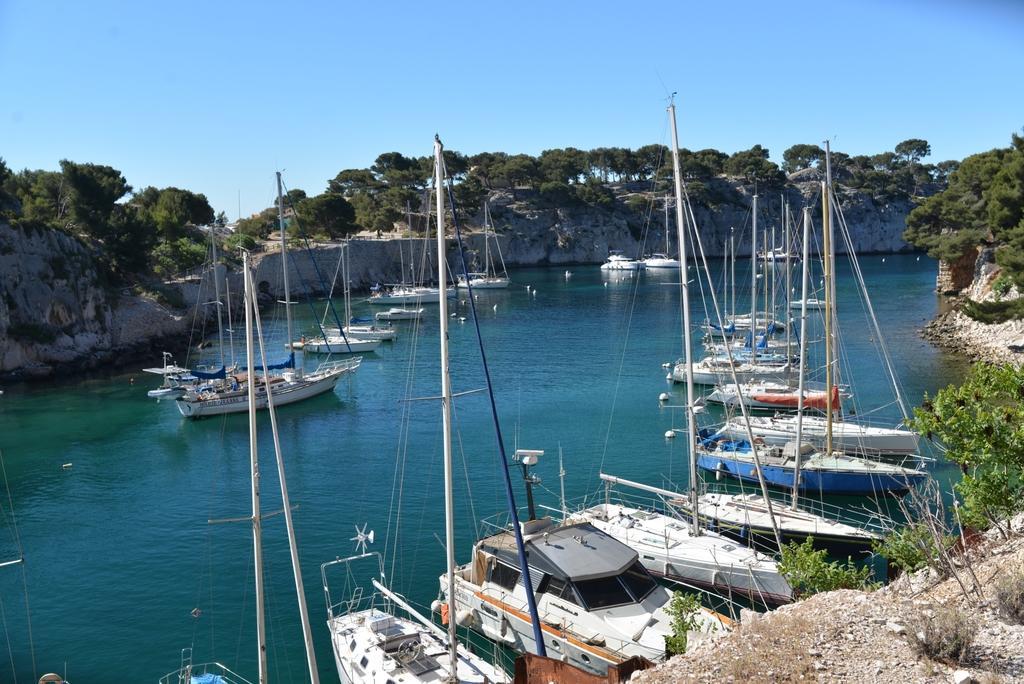Describe this image in one or two sentences. In this image I can see the boats on the water. I can see the water in blue color. To the side of the water I can see many rocks and trees. In the background I can see the sky. 